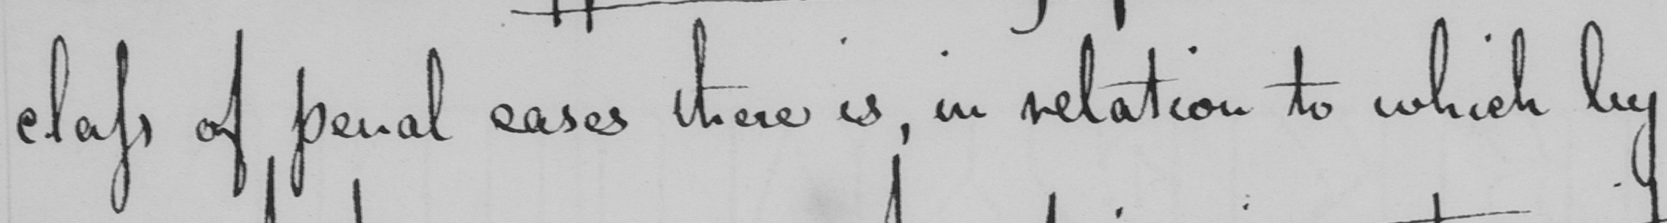Transcribe the text shown in this historical manuscript line. class of penal cases there is, in relation to which by 